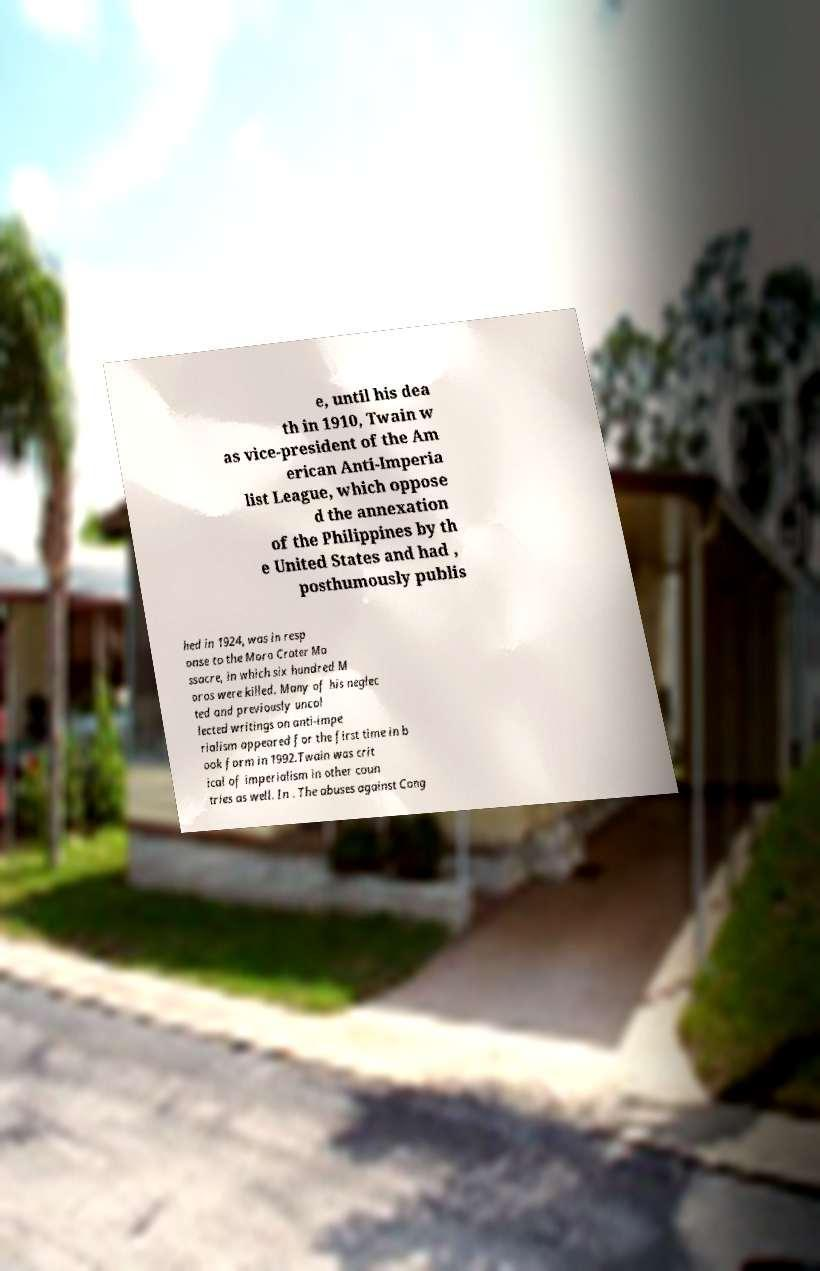Could you assist in decoding the text presented in this image and type it out clearly? e, until his dea th in 1910, Twain w as vice-president of the Am erican Anti-Imperia list League, which oppose d the annexation of the Philippines by th e United States and had , posthumously publis hed in 1924, was in resp onse to the Moro Crater Ma ssacre, in which six hundred M oros were killed. Many of his neglec ted and previously uncol lected writings on anti-impe rialism appeared for the first time in b ook form in 1992.Twain was crit ical of imperialism in other coun tries as well. In . The abuses against Cong 